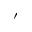Convert formula to latex. <formula><loc_0><loc_0><loc_500><loc_500>^ { \prime }</formula> 